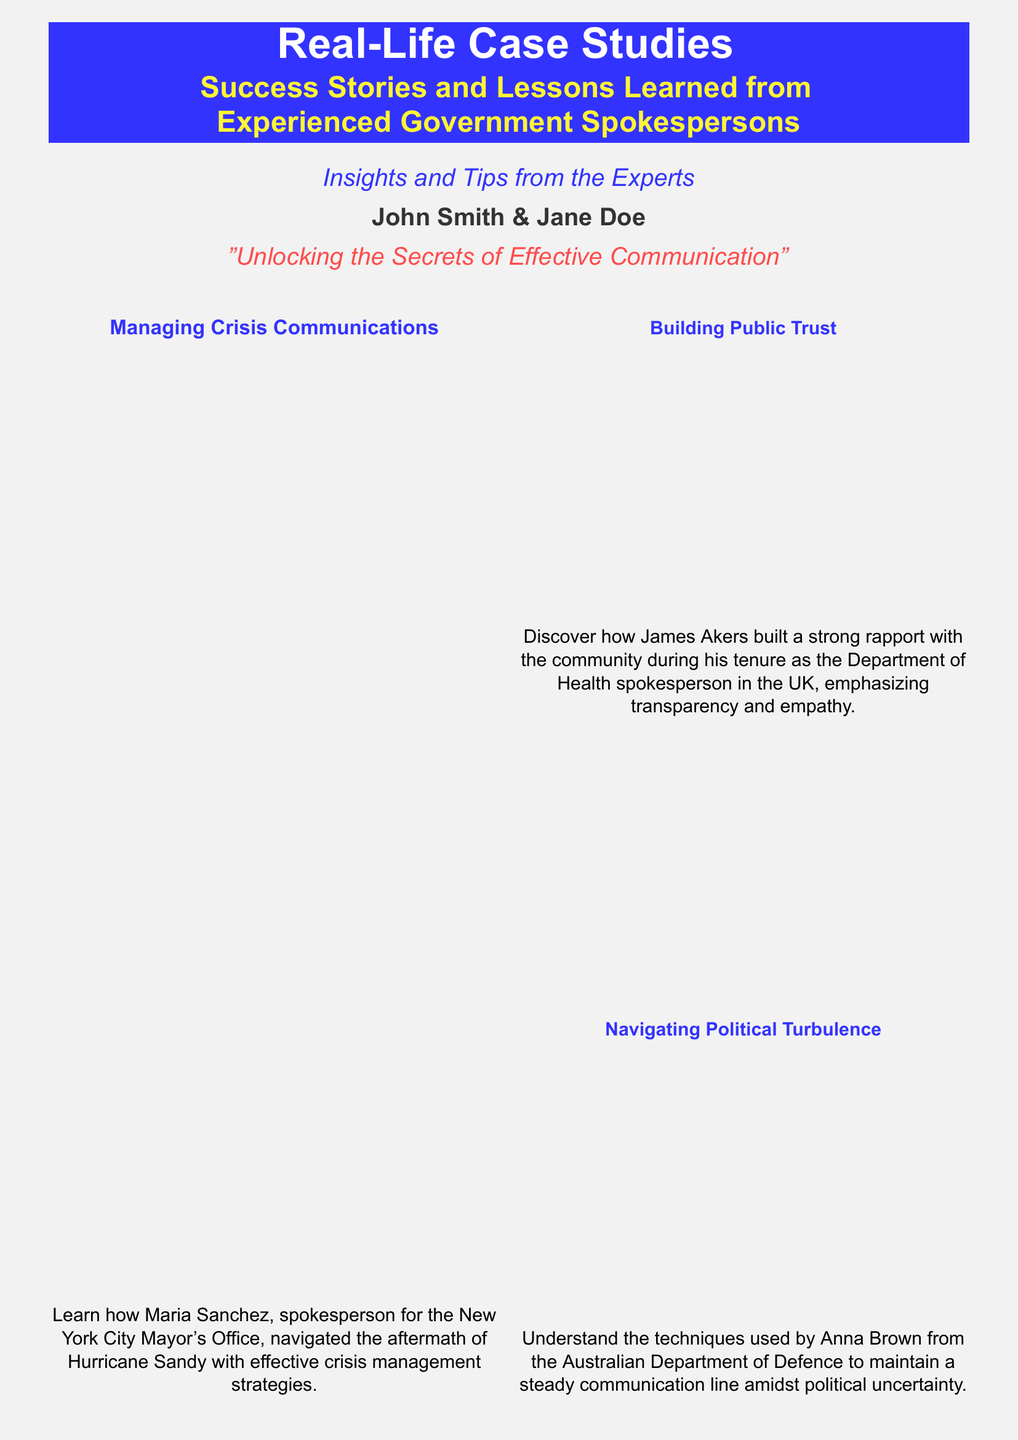What is the title of the book? The title is clearly stated at the top of the cover.
Answer: Real-Life Case Studies Who are the authors of the book? The authors' names are provided at the bottom of the cover.
Answer: John Smith & Jane Doe What is the publication date? The publication date appears in the footer section of the cover.
Answer: 2023-12-15 Which organization did Maria Sanchez represent? The specific organization mentioned in the case study description about crisis communication.
Answer: New York City Mayor's Office What is a primary theme of the book? The overarching theme is indicated by the subtitle.
Answer: Success Stories and Lessons Learned How many case studies are summarized in the columns? The number of cases can be counted from the sections provided in the document.
Answer: Four What is the ISBN number of the book? The ISBN number is listed in the footer area of the cover.
Answer: 978-3-16-148410-0 Who is quoted as the Chief Communications Officer? The person's title and name are presented in a two-column summary at the bottom.
Answer: Emma Roberts What is the main focus of Jeff Lin's case study? The specific focus of Jeff Lin's case is mentioned in the description of his case study.
Answer: Engaging with Digital Media How is the final quote in the document described? The quote’s context and speaker can be identified in the summary.
Answer: A masterclass in handling media relations 